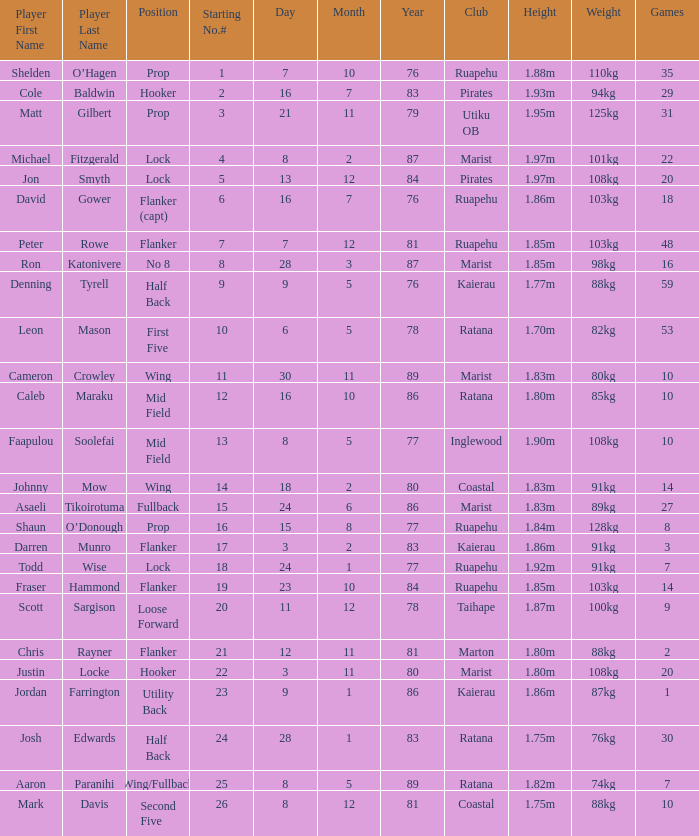What is the date of birth for the player in the Inglewood club? 80577.0. 